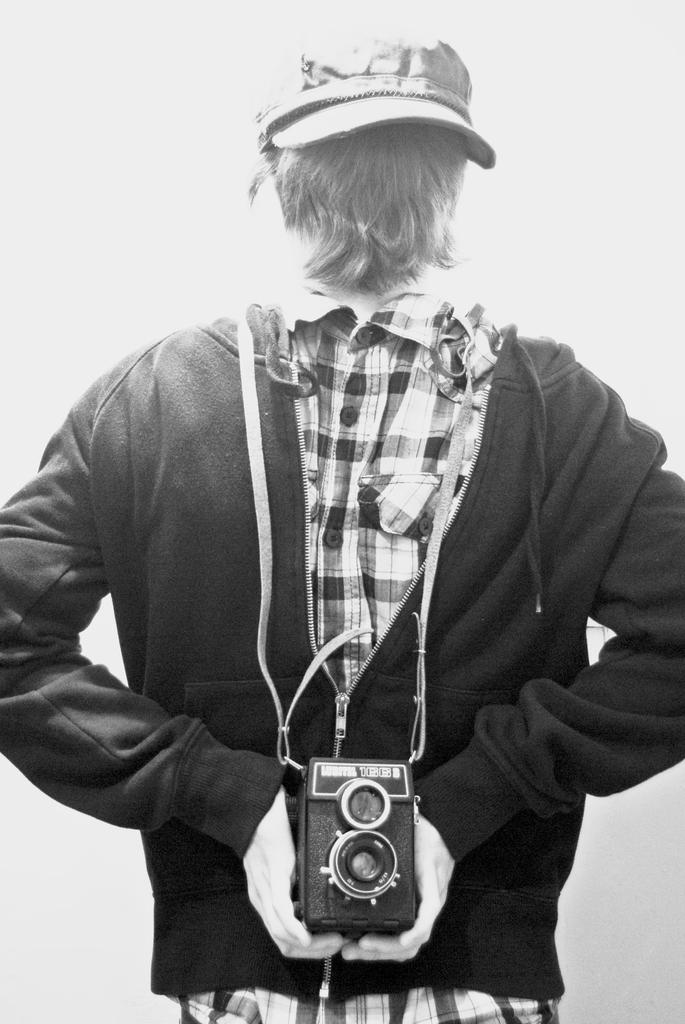What is the main subject of the image? There is a person in the image. What is the person doing in the image? The person is facing away from the camera. What is the person holding in their hand? The person is holding a camera in their hand. What type of clothing is the person wearing? The person is wearing a checked shirt and a cap. What type of bean is being used as a prop in the image? There is no bean present in the image; it features a person holding a camera. 